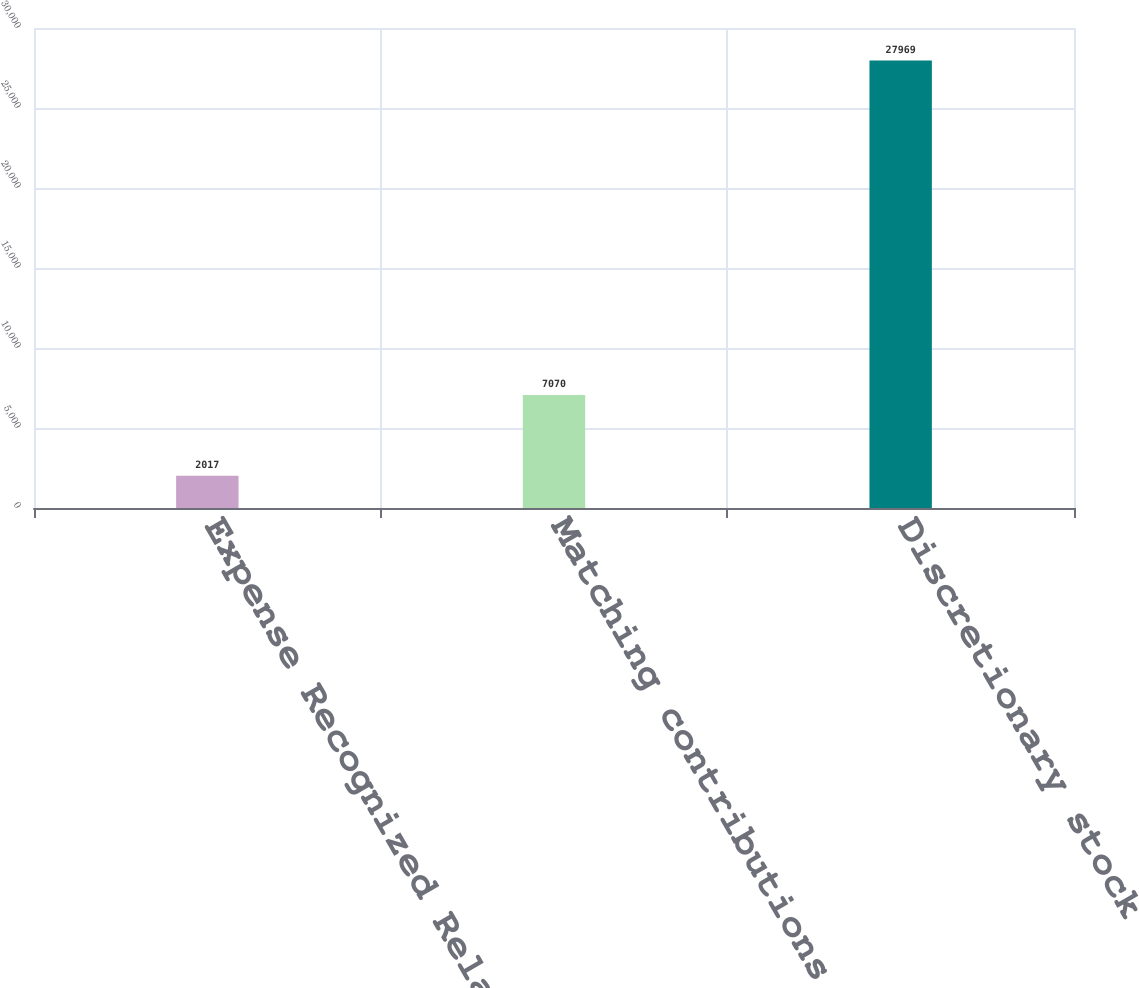Convert chart to OTSL. <chart><loc_0><loc_0><loc_500><loc_500><bar_chart><fcel>Expense Recognized Related to<fcel>Matching contributions net of<fcel>Discretionary stock<nl><fcel>2017<fcel>7070<fcel>27969<nl></chart> 